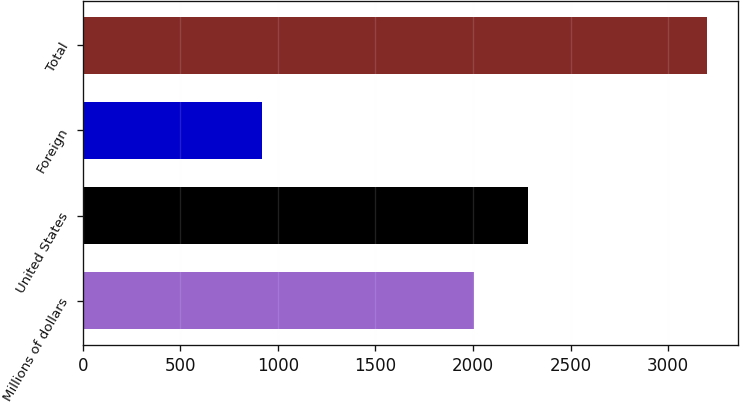Convert chart. <chart><loc_0><loc_0><loc_500><loc_500><bar_chart><fcel>Millions of dollars<fcel>United States<fcel>Foreign<fcel>Total<nl><fcel>2006<fcel>2280<fcel>919<fcel>3199<nl></chart> 